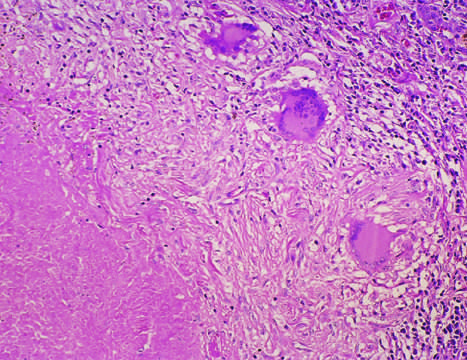does mycobacterium avium infection in a duodenal biopsy from a patient with aids show central granular caseation surrounded by epithelioid and multinucleate giant cells?
Answer the question using a single word or phrase. No 